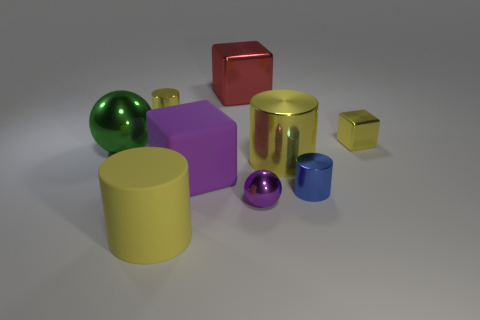There is a large red object that is made of the same material as the big ball; what is its shape?
Provide a short and direct response. Cube. Is the number of small purple balls on the right side of the rubber block less than the number of balls?
Make the answer very short. Yes. Is the small purple thing the same shape as the green metal object?
Ensure brevity in your answer.  Yes. How many rubber things are either cyan spheres or small yellow things?
Give a very brief answer. 0. Is there a green object of the same size as the rubber cylinder?
Your answer should be compact. Yes. There is a large metal object that is the same color as the matte cylinder; what shape is it?
Make the answer very short. Cylinder. What number of yellow cylinders have the same size as the blue shiny object?
Offer a terse response. 1. Is the size of the purple object behind the blue cylinder the same as the cube that is right of the purple ball?
Your answer should be compact. No. How many objects are big brown metal objects or large yellow objects to the left of the big red metal cube?
Your response must be concise. 1. The large metal ball has what color?
Provide a succinct answer. Green. 